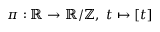Convert formula to latex. <formula><loc_0><loc_0><loc_500><loc_500>\pi \colon \mathbb { R } \to \mathbb { R } / \mathbb { Z } , \ t \mapsto [ t ]</formula> 